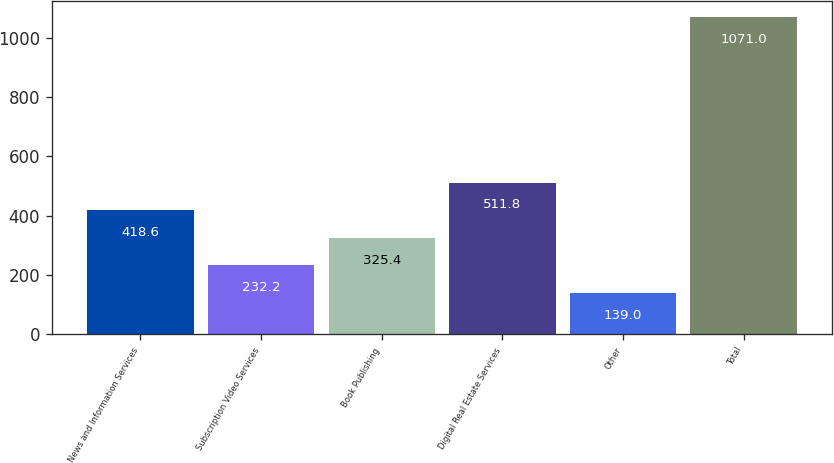<chart> <loc_0><loc_0><loc_500><loc_500><bar_chart><fcel>News and Information Services<fcel>Subscription Video Services<fcel>Book Publishing<fcel>Digital Real Estate Services<fcel>Other<fcel>Total<nl><fcel>418.6<fcel>232.2<fcel>325.4<fcel>511.8<fcel>139<fcel>1071<nl></chart> 